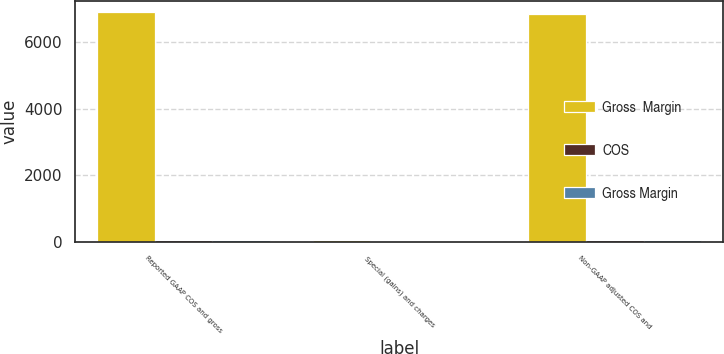Convert chart to OTSL. <chart><loc_0><loc_0><loc_500><loc_500><stacked_bar_chart><ecel><fcel>Reported GAAP COS and gross<fcel>Special (gains) and charges<fcel>Non-GAAP adjusted COS and<nl><fcel>Gross  Margin<fcel>6898.9<fcel>66<fcel>6832.9<nl><fcel>COS<fcel>47.5<fcel>0.5<fcel>48<nl><fcel>Gross Margin<fcel>46.2<fcel>0.1<fcel>46.3<nl></chart> 